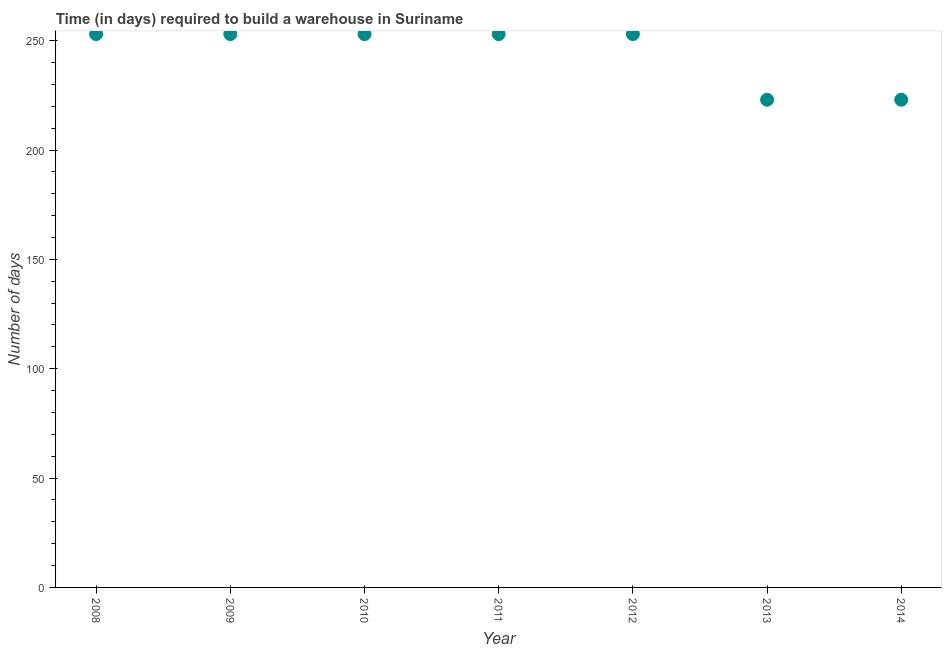What is the time required to build a warehouse in 2013?
Make the answer very short. 223. Across all years, what is the maximum time required to build a warehouse?
Give a very brief answer. 253. Across all years, what is the minimum time required to build a warehouse?
Offer a very short reply. 223. In which year was the time required to build a warehouse maximum?
Ensure brevity in your answer.  2008. What is the sum of the time required to build a warehouse?
Provide a succinct answer. 1711. What is the difference between the time required to build a warehouse in 2008 and 2014?
Make the answer very short. 30. What is the average time required to build a warehouse per year?
Provide a short and direct response. 244.43. What is the median time required to build a warehouse?
Offer a very short reply. 253. In how many years, is the time required to build a warehouse greater than 240 days?
Your answer should be very brief. 5. What is the ratio of the time required to build a warehouse in 2011 to that in 2014?
Offer a terse response. 1.13. Is the time required to build a warehouse in 2008 less than that in 2013?
Your response must be concise. No. Is the sum of the time required to build a warehouse in 2008 and 2011 greater than the maximum time required to build a warehouse across all years?
Offer a very short reply. Yes. What is the difference between the highest and the lowest time required to build a warehouse?
Ensure brevity in your answer.  30. Does the time required to build a warehouse monotonically increase over the years?
Your answer should be compact. No. Are the values on the major ticks of Y-axis written in scientific E-notation?
Make the answer very short. No. Does the graph contain any zero values?
Give a very brief answer. No. Does the graph contain grids?
Ensure brevity in your answer.  No. What is the title of the graph?
Provide a succinct answer. Time (in days) required to build a warehouse in Suriname. What is the label or title of the Y-axis?
Your answer should be very brief. Number of days. What is the Number of days in 2008?
Your answer should be compact. 253. What is the Number of days in 2009?
Provide a short and direct response. 253. What is the Number of days in 2010?
Give a very brief answer. 253. What is the Number of days in 2011?
Offer a very short reply. 253. What is the Number of days in 2012?
Offer a very short reply. 253. What is the Number of days in 2013?
Give a very brief answer. 223. What is the Number of days in 2014?
Offer a terse response. 223. What is the difference between the Number of days in 2008 and 2009?
Your answer should be very brief. 0. What is the difference between the Number of days in 2008 and 2011?
Make the answer very short. 0. What is the difference between the Number of days in 2008 and 2012?
Provide a succinct answer. 0. What is the difference between the Number of days in 2008 and 2013?
Your answer should be compact. 30. What is the difference between the Number of days in 2008 and 2014?
Provide a succinct answer. 30. What is the difference between the Number of days in 2009 and 2010?
Your response must be concise. 0. What is the difference between the Number of days in 2009 and 2011?
Give a very brief answer. 0. What is the difference between the Number of days in 2009 and 2012?
Your response must be concise. 0. What is the difference between the Number of days in 2009 and 2013?
Make the answer very short. 30. What is the difference between the Number of days in 2009 and 2014?
Offer a terse response. 30. What is the difference between the Number of days in 2010 and 2013?
Your answer should be compact. 30. What is the difference between the Number of days in 2011 and 2012?
Your answer should be compact. 0. What is the difference between the Number of days in 2011 and 2014?
Provide a short and direct response. 30. What is the difference between the Number of days in 2012 and 2013?
Give a very brief answer. 30. What is the difference between the Number of days in 2013 and 2014?
Offer a terse response. 0. What is the ratio of the Number of days in 2008 to that in 2009?
Ensure brevity in your answer.  1. What is the ratio of the Number of days in 2008 to that in 2011?
Offer a terse response. 1. What is the ratio of the Number of days in 2008 to that in 2013?
Provide a short and direct response. 1.14. What is the ratio of the Number of days in 2008 to that in 2014?
Provide a short and direct response. 1.14. What is the ratio of the Number of days in 2009 to that in 2012?
Give a very brief answer. 1. What is the ratio of the Number of days in 2009 to that in 2013?
Provide a short and direct response. 1.14. What is the ratio of the Number of days in 2009 to that in 2014?
Your answer should be compact. 1.14. What is the ratio of the Number of days in 2010 to that in 2011?
Offer a terse response. 1. What is the ratio of the Number of days in 2010 to that in 2013?
Give a very brief answer. 1.14. What is the ratio of the Number of days in 2010 to that in 2014?
Offer a very short reply. 1.14. What is the ratio of the Number of days in 2011 to that in 2013?
Keep it short and to the point. 1.14. What is the ratio of the Number of days in 2011 to that in 2014?
Keep it short and to the point. 1.14. What is the ratio of the Number of days in 2012 to that in 2013?
Ensure brevity in your answer.  1.14. What is the ratio of the Number of days in 2012 to that in 2014?
Your answer should be compact. 1.14. 